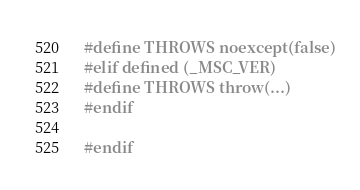<code> <loc_0><loc_0><loc_500><loc_500><_C++_>#define THROWS noexcept(false)
#elif defined (_MSC_VER)
#define THROWS throw(...)
#endif

#endif
</code> 